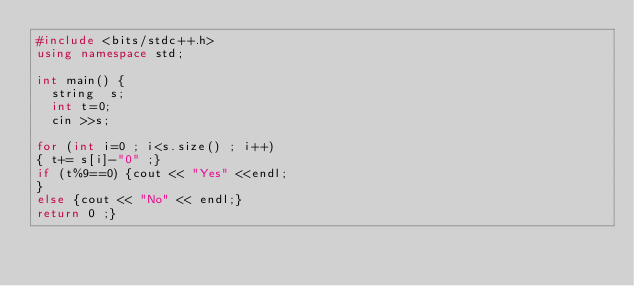Convert code to text. <code><loc_0><loc_0><loc_500><loc_500><_C++_>#include <bits/stdc++.h>
using namespace std;

int main() {
  string  s;
  int t=0;
  cin >>s;

for (int i=0 ; i<s.size() ; i++)  
{ t+= s[i]-"0" ;}
if (t%9==0) {cout << "Yes" <<endl;
}
else {cout << "No" << endl;}
return 0 ;}
</code> 